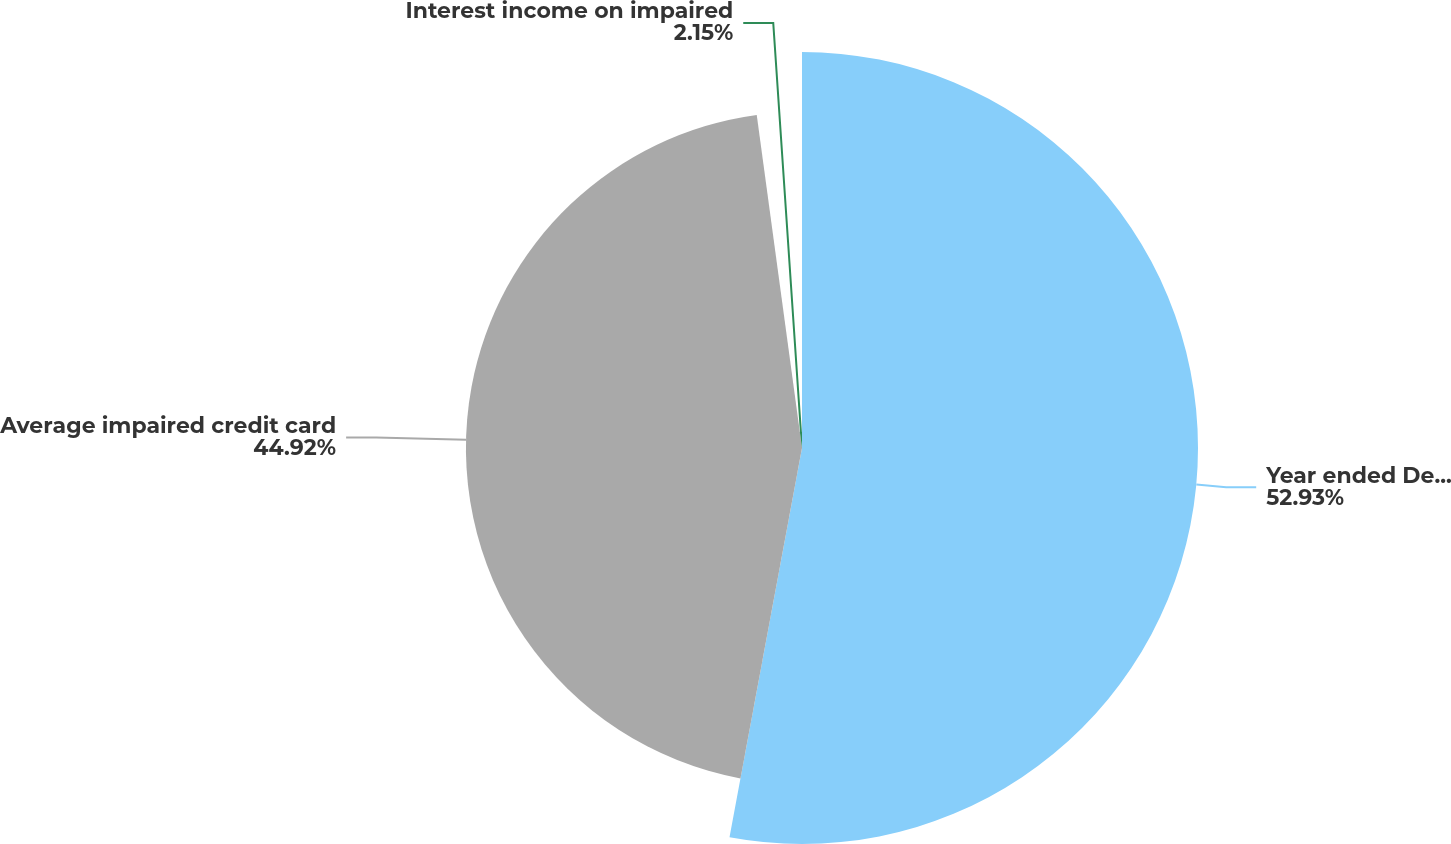Convert chart. <chart><loc_0><loc_0><loc_500><loc_500><pie_chart><fcel>Year ended December 31 (in<fcel>Average impaired credit card<fcel>Interest income on impaired<nl><fcel>52.93%<fcel>44.92%<fcel>2.15%<nl></chart> 